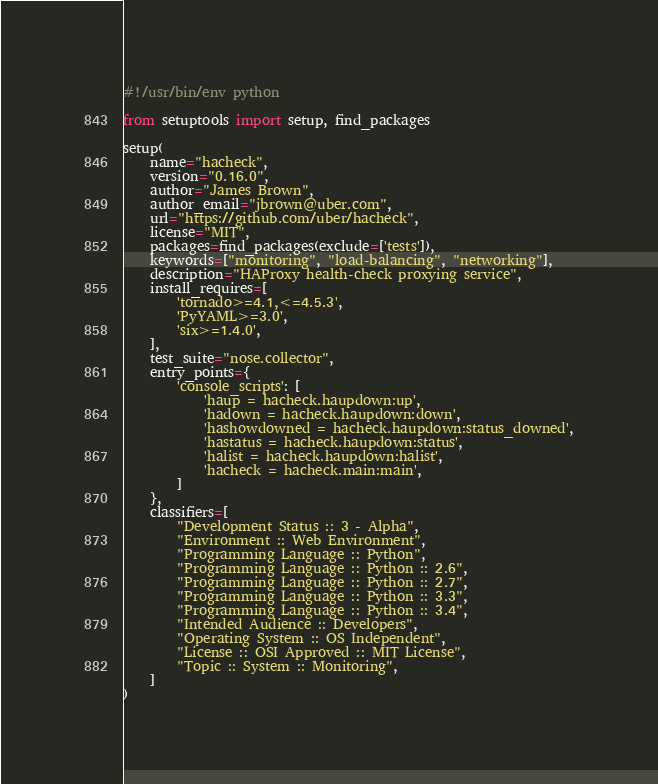Convert code to text. <code><loc_0><loc_0><loc_500><loc_500><_Python_>#!/usr/bin/env python

from setuptools import setup, find_packages

setup(
    name="hacheck",
    version="0.16.0",
    author="James Brown",
    author_email="jbrown@uber.com",
    url="https://github.com/uber/hacheck",
    license="MIT",
    packages=find_packages(exclude=['tests']),
    keywords=["monitoring", "load-balancing", "networking"],
    description="HAProxy health-check proxying service",
    install_requires=[
        'tornado>=4.1,<=4.5.3',
        'PyYAML>=3.0',
        'six>=1.4.0',
    ],
    test_suite="nose.collector",
    entry_points={
        'console_scripts': [
            'haup = hacheck.haupdown:up',
            'hadown = hacheck.haupdown:down',
            'hashowdowned = hacheck.haupdown:status_downed',
            'hastatus = hacheck.haupdown:status',
            'halist = hacheck.haupdown:halist',
            'hacheck = hacheck.main:main',
        ]
    },
    classifiers=[
        "Development Status :: 3 - Alpha",
        "Environment :: Web Environment",
        "Programming Language :: Python",
        "Programming Language :: Python :: 2.6",
        "Programming Language :: Python :: 2.7",
        "Programming Language :: Python :: 3.3",
        "Programming Language :: Python :: 3.4",
        "Intended Audience :: Developers",
        "Operating System :: OS Independent",
        "License :: OSI Approved :: MIT License",
        "Topic :: System :: Monitoring",
    ]
)
</code> 